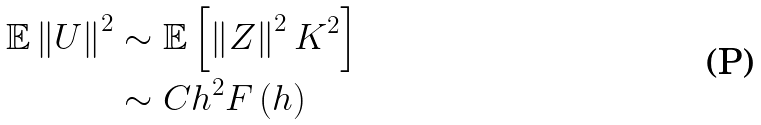Convert formula to latex. <formula><loc_0><loc_0><loc_500><loc_500>\mathbb { E } \left \| U \right \| ^ { 2 } & \sim \mathbb { E } \left [ \left \| Z \right \| ^ { 2 } K ^ { 2 } \right ] \\ & \sim C h ^ { 2 } F \left ( h \right )</formula> 